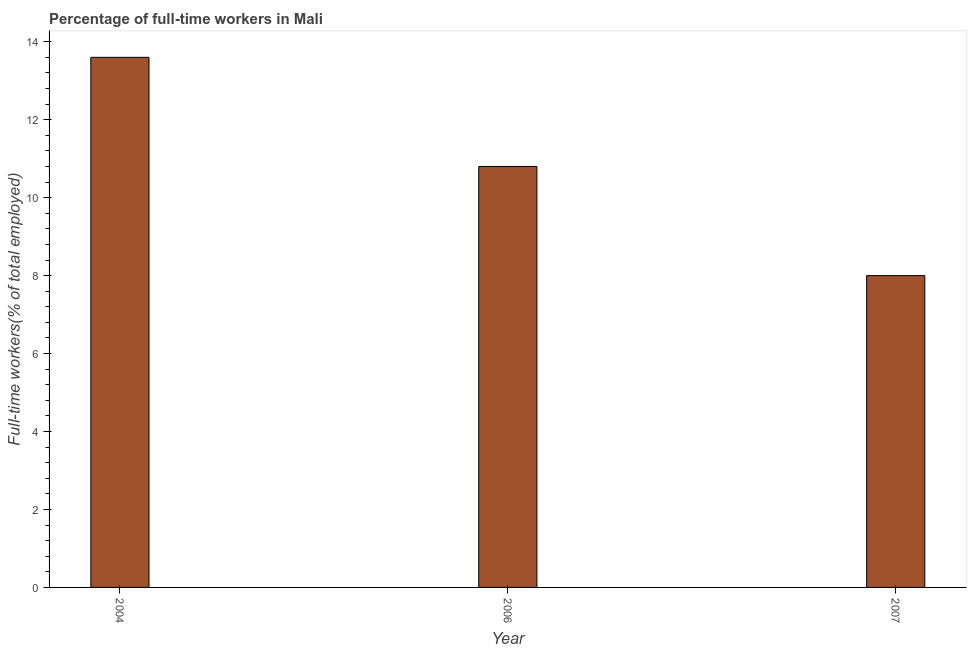What is the title of the graph?
Ensure brevity in your answer.  Percentage of full-time workers in Mali. What is the label or title of the Y-axis?
Provide a succinct answer. Full-time workers(% of total employed). What is the percentage of full-time workers in 2004?
Provide a short and direct response. 13.6. Across all years, what is the maximum percentage of full-time workers?
Keep it short and to the point. 13.6. Across all years, what is the minimum percentage of full-time workers?
Keep it short and to the point. 8. What is the sum of the percentage of full-time workers?
Your answer should be compact. 32.4. What is the difference between the percentage of full-time workers in 2004 and 2007?
Ensure brevity in your answer.  5.6. What is the median percentage of full-time workers?
Keep it short and to the point. 10.8. Is the difference between the percentage of full-time workers in 2006 and 2007 greater than the difference between any two years?
Provide a succinct answer. No. What is the difference between the highest and the second highest percentage of full-time workers?
Make the answer very short. 2.8. What is the difference between the highest and the lowest percentage of full-time workers?
Keep it short and to the point. 5.6. Are all the bars in the graph horizontal?
Provide a short and direct response. No. How many years are there in the graph?
Your answer should be compact. 3. What is the difference between two consecutive major ticks on the Y-axis?
Offer a very short reply. 2. What is the Full-time workers(% of total employed) of 2004?
Ensure brevity in your answer.  13.6. What is the Full-time workers(% of total employed) of 2006?
Provide a succinct answer. 10.8. What is the Full-time workers(% of total employed) of 2007?
Give a very brief answer. 8. What is the difference between the Full-time workers(% of total employed) in 2004 and 2006?
Give a very brief answer. 2.8. What is the difference between the Full-time workers(% of total employed) in 2004 and 2007?
Provide a succinct answer. 5.6. What is the ratio of the Full-time workers(% of total employed) in 2004 to that in 2006?
Offer a terse response. 1.26. What is the ratio of the Full-time workers(% of total employed) in 2004 to that in 2007?
Ensure brevity in your answer.  1.7. What is the ratio of the Full-time workers(% of total employed) in 2006 to that in 2007?
Provide a succinct answer. 1.35. 